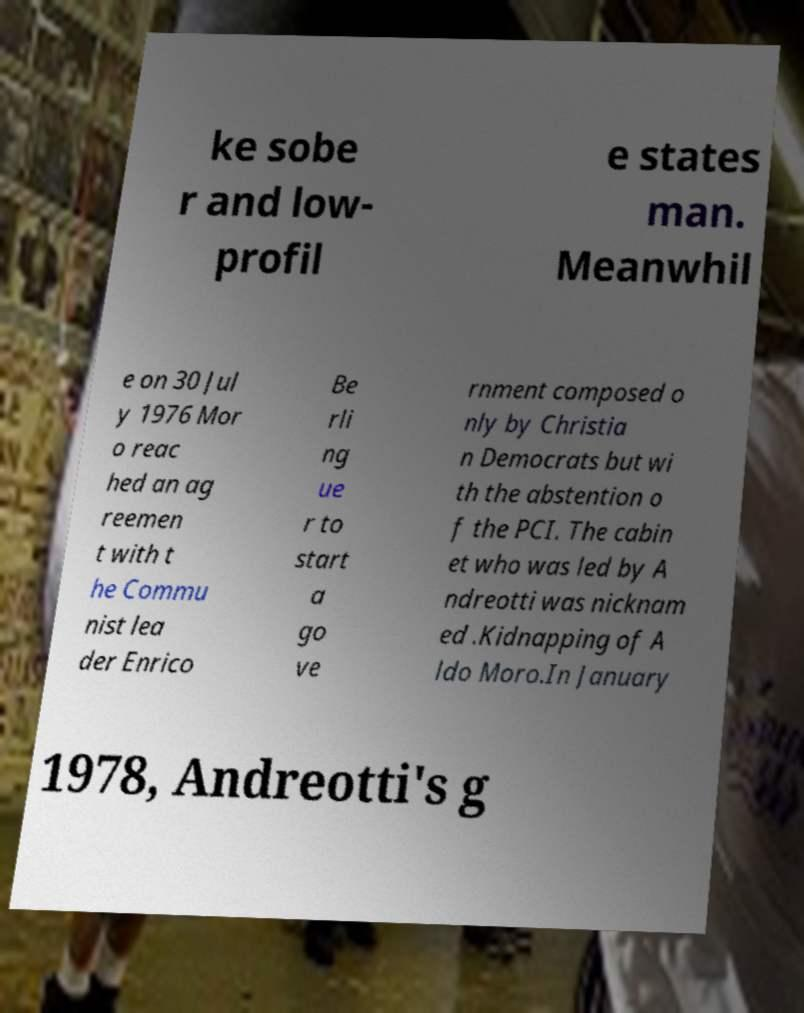There's text embedded in this image that I need extracted. Can you transcribe it verbatim? ke sobe r and low- profil e states man. Meanwhil e on 30 Jul y 1976 Mor o reac hed an ag reemen t with t he Commu nist lea der Enrico Be rli ng ue r to start a go ve rnment composed o nly by Christia n Democrats but wi th the abstention o f the PCI. The cabin et who was led by A ndreotti was nicknam ed .Kidnapping of A ldo Moro.In January 1978, Andreotti's g 